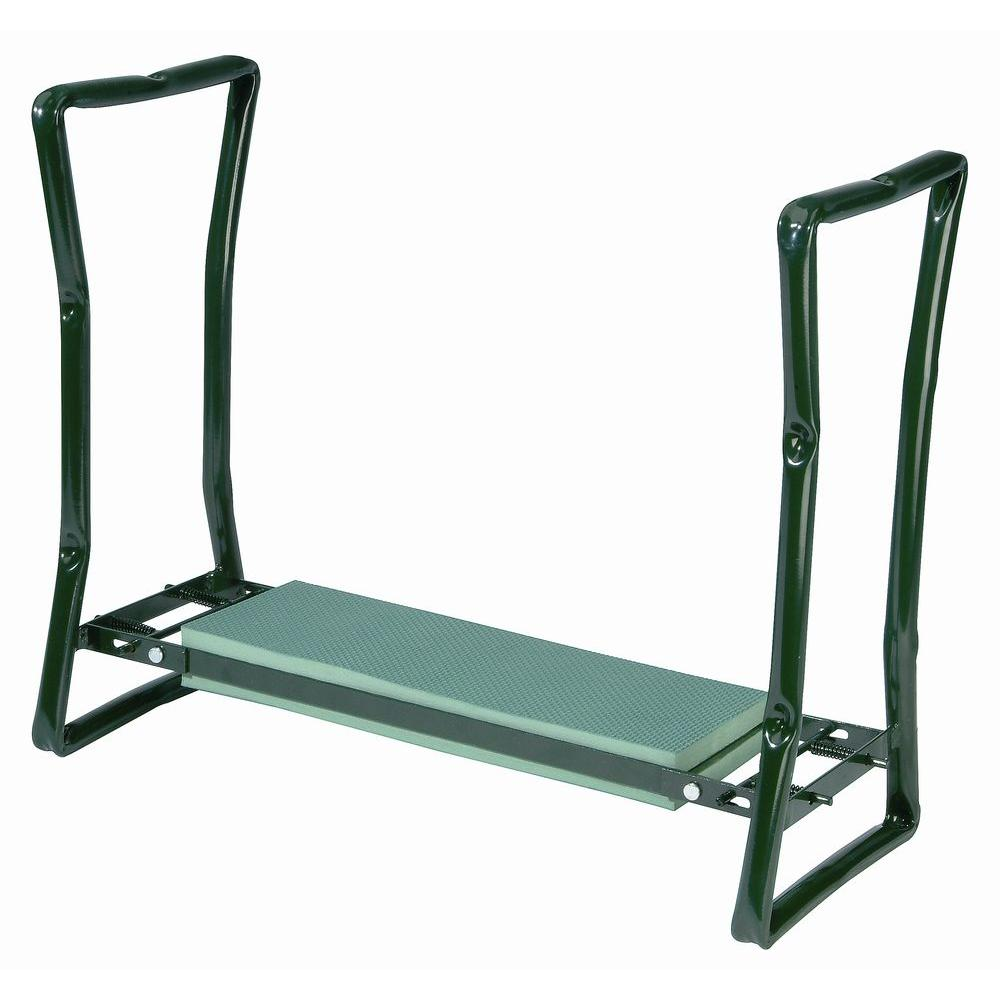Could this squat stand be modified for use in small home gyms? If so, how? Certainly, this squat stand's compact and straightforward design makes it suitable for small home gyms. To further enhance its functionality in a limited space, one could add storage hooks for weights along the sides or perhaps integrate foldable features for easy storage when not in use. Additionally, attaching rubber pads at the base could improve stability and protect floor surfaces, making it both a practical and adaptable choice for home fitness enthusiasts. 